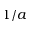Convert formula to latex. <formula><loc_0><loc_0><loc_500><loc_500>1 / a</formula> 